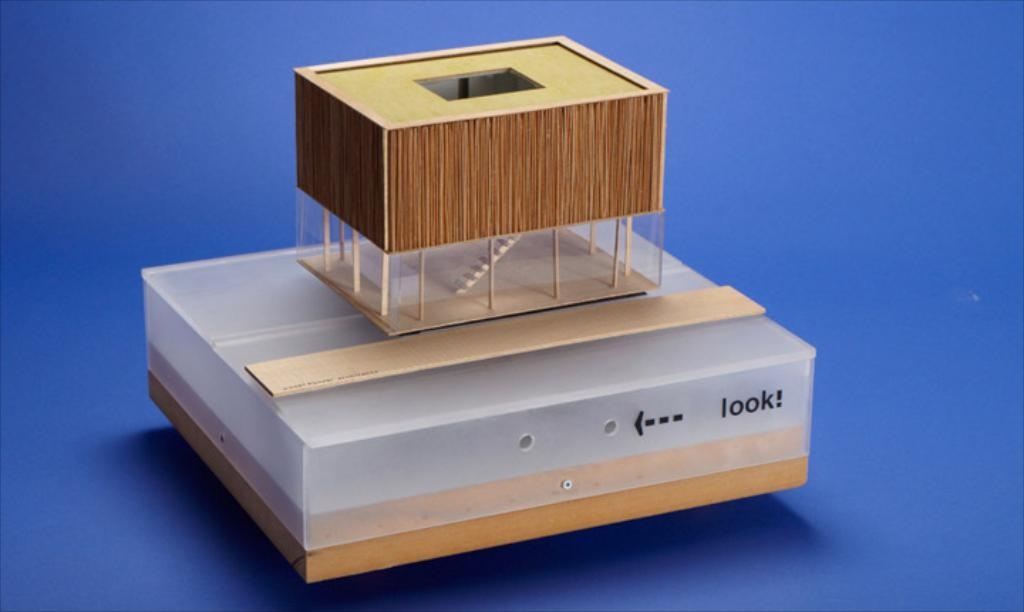<image>
Describe the image concisely. A small wooden figurine is placed atop a box with two holes and an arrow pointing to the holes that says look! 